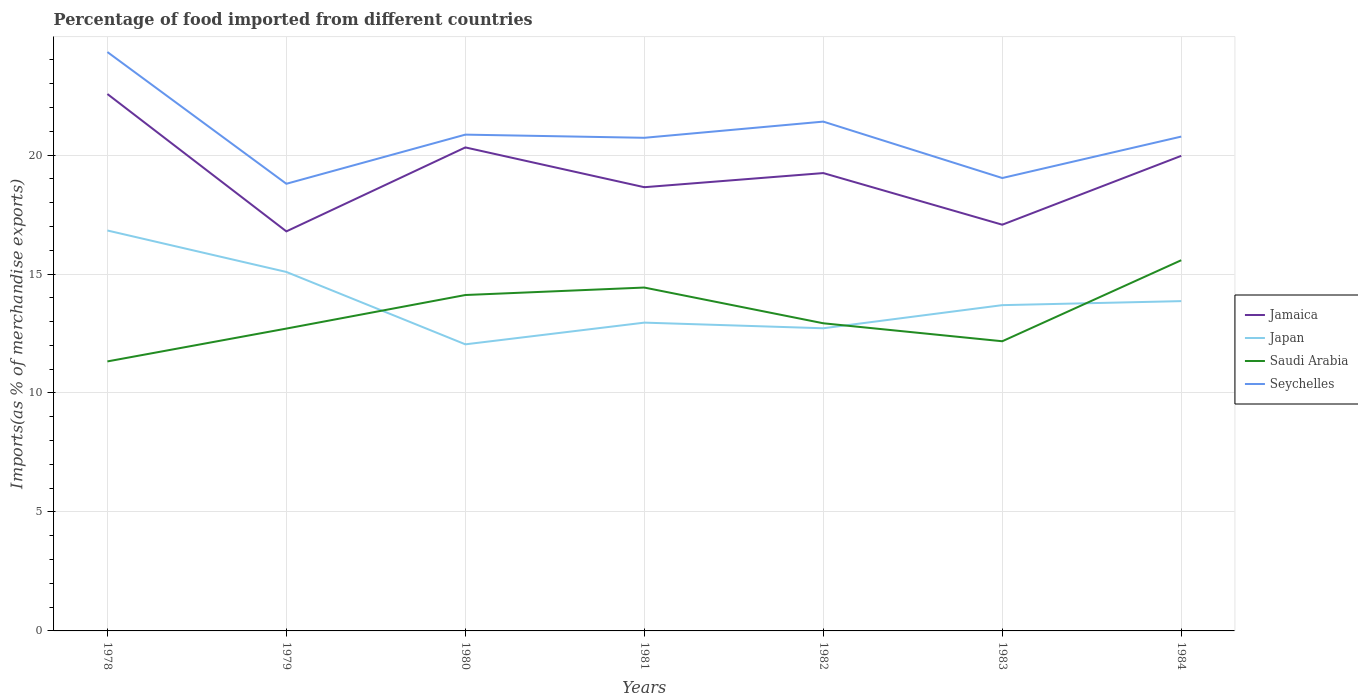Is the number of lines equal to the number of legend labels?
Provide a succinct answer. Yes. Across all years, what is the maximum percentage of imports to different countries in Japan?
Offer a very short reply. 12.04. In which year was the percentage of imports to different countries in Jamaica maximum?
Give a very brief answer. 1979. What is the total percentage of imports to different countries in Saudi Arabia in the graph?
Provide a succinct answer. -0.31. What is the difference between the highest and the second highest percentage of imports to different countries in Saudi Arabia?
Keep it short and to the point. 4.25. What is the difference between the highest and the lowest percentage of imports to different countries in Seychelles?
Provide a succinct answer. 3. How many lines are there?
Give a very brief answer. 4. How many years are there in the graph?
Provide a short and direct response. 7. What is the difference between two consecutive major ticks on the Y-axis?
Your answer should be very brief. 5. Are the values on the major ticks of Y-axis written in scientific E-notation?
Give a very brief answer. No. Does the graph contain any zero values?
Offer a very short reply. No. Does the graph contain grids?
Offer a very short reply. Yes. How are the legend labels stacked?
Offer a terse response. Vertical. What is the title of the graph?
Your answer should be very brief. Percentage of food imported from different countries. What is the label or title of the Y-axis?
Your answer should be compact. Imports(as % of merchandise exports). What is the Imports(as % of merchandise exports) in Jamaica in 1978?
Provide a short and direct response. 22.56. What is the Imports(as % of merchandise exports) in Japan in 1978?
Your answer should be compact. 16.83. What is the Imports(as % of merchandise exports) of Saudi Arabia in 1978?
Your response must be concise. 11.33. What is the Imports(as % of merchandise exports) in Seychelles in 1978?
Ensure brevity in your answer.  24.33. What is the Imports(as % of merchandise exports) in Jamaica in 1979?
Offer a very short reply. 16.79. What is the Imports(as % of merchandise exports) in Japan in 1979?
Offer a terse response. 15.09. What is the Imports(as % of merchandise exports) in Saudi Arabia in 1979?
Provide a short and direct response. 12.71. What is the Imports(as % of merchandise exports) of Seychelles in 1979?
Give a very brief answer. 18.79. What is the Imports(as % of merchandise exports) of Jamaica in 1980?
Offer a very short reply. 20.32. What is the Imports(as % of merchandise exports) in Japan in 1980?
Provide a succinct answer. 12.04. What is the Imports(as % of merchandise exports) of Saudi Arabia in 1980?
Provide a succinct answer. 14.12. What is the Imports(as % of merchandise exports) of Seychelles in 1980?
Offer a terse response. 20.86. What is the Imports(as % of merchandise exports) in Jamaica in 1981?
Provide a short and direct response. 18.65. What is the Imports(as % of merchandise exports) of Japan in 1981?
Your answer should be compact. 12.96. What is the Imports(as % of merchandise exports) in Saudi Arabia in 1981?
Keep it short and to the point. 14.43. What is the Imports(as % of merchandise exports) of Seychelles in 1981?
Make the answer very short. 20.72. What is the Imports(as % of merchandise exports) of Jamaica in 1982?
Your answer should be very brief. 19.24. What is the Imports(as % of merchandise exports) in Japan in 1982?
Provide a short and direct response. 12.72. What is the Imports(as % of merchandise exports) in Saudi Arabia in 1982?
Provide a succinct answer. 12.93. What is the Imports(as % of merchandise exports) in Seychelles in 1982?
Give a very brief answer. 21.4. What is the Imports(as % of merchandise exports) of Jamaica in 1983?
Your answer should be very brief. 17.07. What is the Imports(as % of merchandise exports) of Japan in 1983?
Make the answer very short. 13.69. What is the Imports(as % of merchandise exports) in Saudi Arabia in 1983?
Offer a terse response. 12.17. What is the Imports(as % of merchandise exports) of Seychelles in 1983?
Keep it short and to the point. 19.03. What is the Imports(as % of merchandise exports) of Jamaica in 1984?
Offer a terse response. 19.97. What is the Imports(as % of merchandise exports) in Japan in 1984?
Make the answer very short. 13.86. What is the Imports(as % of merchandise exports) in Saudi Arabia in 1984?
Your answer should be very brief. 15.58. What is the Imports(as % of merchandise exports) of Seychelles in 1984?
Your answer should be very brief. 20.78. Across all years, what is the maximum Imports(as % of merchandise exports) of Jamaica?
Ensure brevity in your answer.  22.56. Across all years, what is the maximum Imports(as % of merchandise exports) of Japan?
Your answer should be compact. 16.83. Across all years, what is the maximum Imports(as % of merchandise exports) of Saudi Arabia?
Provide a succinct answer. 15.58. Across all years, what is the maximum Imports(as % of merchandise exports) in Seychelles?
Ensure brevity in your answer.  24.33. Across all years, what is the minimum Imports(as % of merchandise exports) in Jamaica?
Provide a short and direct response. 16.79. Across all years, what is the minimum Imports(as % of merchandise exports) of Japan?
Provide a succinct answer. 12.04. Across all years, what is the minimum Imports(as % of merchandise exports) of Saudi Arabia?
Your answer should be compact. 11.33. Across all years, what is the minimum Imports(as % of merchandise exports) in Seychelles?
Give a very brief answer. 18.79. What is the total Imports(as % of merchandise exports) of Jamaica in the graph?
Provide a short and direct response. 134.61. What is the total Imports(as % of merchandise exports) of Japan in the graph?
Ensure brevity in your answer.  97.19. What is the total Imports(as % of merchandise exports) of Saudi Arabia in the graph?
Ensure brevity in your answer.  93.26. What is the total Imports(as % of merchandise exports) of Seychelles in the graph?
Provide a short and direct response. 145.92. What is the difference between the Imports(as % of merchandise exports) of Jamaica in 1978 and that in 1979?
Keep it short and to the point. 5.77. What is the difference between the Imports(as % of merchandise exports) of Japan in 1978 and that in 1979?
Your response must be concise. 1.74. What is the difference between the Imports(as % of merchandise exports) of Saudi Arabia in 1978 and that in 1979?
Provide a succinct answer. -1.38. What is the difference between the Imports(as % of merchandise exports) of Seychelles in 1978 and that in 1979?
Your answer should be compact. 5.54. What is the difference between the Imports(as % of merchandise exports) in Jamaica in 1978 and that in 1980?
Offer a very short reply. 2.24. What is the difference between the Imports(as % of merchandise exports) in Japan in 1978 and that in 1980?
Make the answer very short. 4.78. What is the difference between the Imports(as % of merchandise exports) of Saudi Arabia in 1978 and that in 1980?
Make the answer very short. -2.79. What is the difference between the Imports(as % of merchandise exports) in Seychelles in 1978 and that in 1980?
Your answer should be very brief. 3.47. What is the difference between the Imports(as % of merchandise exports) in Jamaica in 1978 and that in 1981?
Make the answer very short. 3.92. What is the difference between the Imports(as % of merchandise exports) in Japan in 1978 and that in 1981?
Offer a terse response. 3.87. What is the difference between the Imports(as % of merchandise exports) of Saudi Arabia in 1978 and that in 1981?
Offer a very short reply. -3.1. What is the difference between the Imports(as % of merchandise exports) in Seychelles in 1978 and that in 1981?
Your answer should be compact. 3.6. What is the difference between the Imports(as % of merchandise exports) in Jamaica in 1978 and that in 1982?
Provide a short and direct response. 3.32. What is the difference between the Imports(as % of merchandise exports) of Japan in 1978 and that in 1982?
Offer a terse response. 4.11. What is the difference between the Imports(as % of merchandise exports) in Saudi Arabia in 1978 and that in 1982?
Provide a short and direct response. -1.6. What is the difference between the Imports(as % of merchandise exports) of Seychelles in 1978 and that in 1982?
Your answer should be very brief. 2.92. What is the difference between the Imports(as % of merchandise exports) in Jamaica in 1978 and that in 1983?
Keep it short and to the point. 5.49. What is the difference between the Imports(as % of merchandise exports) in Japan in 1978 and that in 1983?
Your response must be concise. 3.14. What is the difference between the Imports(as % of merchandise exports) of Saudi Arabia in 1978 and that in 1983?
Provide a short and direct response. -0.85. What is the difference between the Imports(as % of merchandise exports) of Seychelles in 1978 and that in 1983?
Make the answer very short. 5.29. What is the difference between the Imports(as % of merchandise exports) of Jamaica in 1978 and that in 1984?
Offer a very short reply. 2.6. What is the difference between the Imports(as % of merchandise exports) of Japan in 1978 and that in 1984?
Your answer should be very brief. 2.97. What is the difference between the Imports(as % of merchandise exports) of Saudi Arabia in 1978 and that in 1984?
Offer a terse response. -4.25. What is the difference between the Imports(as % of merchandise exports) in Seychelles in 1978 and that in 1984?
Offer a terse response. 3.55. What is the difference between the Imports(as % of merchandise exports) in Jamaica in 1979 and that in 1980?
Your response must be concise. -3.53. What is the difference between the Imports(as % of merchandise exports) in Japan in 1979 and that in 1980?
Offer a very short reply. 3.04. What is the difference between the Imports(as % of merchandise exports) of Saudi Arabia in 1979 and that in 1980?
Provide a succinct answer. -1.41. What is the difference between the Imports(as % of merchandise exports) of Seychelles in 1979 and that in 1980?
Your response must be concise. -2.07. What is the difference between the Imports(as % of merchandise exports) in Jamaica in 1979 and that in 1981?
Give a very brief answer. -1.86. What is the difference between the Imports(as % of merchandise exports) in Japan in 1979 and that in 1981?
Your answer should be very brief. 2.13. What is the difference between the Imports(as % of merchandise exports) of Saudi Arabia in 1979 and that in 1981?
Offer a terse response. -1.72. What is the difference between the Imports(as % of merchandise exports) of Seychelles in 1979 and that in 1981?
Offer a terse response. -1.93. What is the difference between the Imports(as % of merchandise exports) in Jamaica in 1979 and that in 1982?
Your response must be concise. -2.45. What is the difference between the Imports(as % of merchandise exports) in Japan in 1979 and that in 1982?
Ensure brevity in your answer.  2.37. What is the difference between the Imports(as % of merchandise exports) in Saudi Arabia in 1979 and that in 1982?
Provide a succinct answer. -0.22. What is the difference between the Imports(as % of merchandise exports) of Seychelles in 1979 and that in 1982?
Provide a short and direct response. -2.61. What is the difference between the Imports(as % of merchandise exports) in Jamaica in 1979 and that in 1983?
Your response must be concise. -0.28. What is the difference between the Imports(as % of merchandise exports) in Japan in 1979 and that in 1983?
Offer a very short reply. 1.39. What is the difference between the Imports(as % of merchandise exports) of Saudi Arabia in 1979 and that in 1983?
Give a very brief answer. 0.53. What is the difference between the Imports(as % of merchandise exports) of Seychelles in 1979 and that in 1983?
Your answer should be compact. -0.24. What is the difference between the Imports(as % of merchandise exports) of Jamaica in 1979 and that in 1984?
Offer a terse response. -3.17. What is the difference between the Imports(as % of merchandise exports) of Japan in 1979 and that in 1984?
Give a very brief answer. 1.23. What is the difference between the Imports(as % of merchandise exports) of Saudi Arabia in 1979 and that in 1984?
Provide a succinct answer. -2.87. What is the difference between the Imports(as % of merchandise exports) of Seychelles in 1979 and that in 1984?
Your response must be concise. -1.98. What is the difference between the Imports(as % of merchandise exports) in Jamaica in 1980 and that in 1981?
Give a very brief answer. 1.67. What is the difference between the Imports(as % of merchandise exports) in Japan in 1980 and that in 1981?
Your answer should be compact. -0.91. What is the difference between the Imports(as % of merchandise exports) of Saudi Arabia in 1980 and that in 1981?
Provide a succinct answer. -0.31. What is the difference between the Imports(as % of merchandise exports) in Seychelles in 1980 and that in 1981?
Your answer should be very brief. 0.13. What is the difference between the Imports(as % of merchandise exports) of Jamaica in 1980 and that in 1982?
Provide a succinct answer. 1.08. What is the difference between the Imports(as % of merchandise exports) in Japan in 1980 and that in 1982?
Provide a succinct answer. -0.68. What is the difference between the Imports(as % of merchandise exports) of Saudi Arabia in 1980 and that in 1982?
Your response must be concise. 1.19. What is the difference between the Imports(as % of merchandise exports) in Seychelles in 1980 and that in 1982?
Offer a very short reply. -0.55. What is the difference between the Imports(as % of merchandise exports) in Jamaica in 1980 and that in 1983?
Offer a very short reply. 3.25. What is the difference between the Imports(as % of merchandise exports) in Japan in 1980 and that in 1983?
Keep it short and to the point. -1.65. What is the difference between the Imports(as % of merchandise exports) of Saudi Arabia in 1980 and that in 1983?
Your answer should be very brief. 1.94. What is the difference between the Imports(as % of merchandise exports) of Seychelles in 1980 and that in 1983?
Your answer should be compact. 1.82. What is the difference between the Imports(as % of merchandise exports) in Jamaica in 1980 and that in 1984?
Your answer should be very brief. 0.35. What is the difference between the Imports(as % of merchandise exports) in Japan in 1980 and that in 1984?
Provide a short and direct response. -1.82. What is the difference between the Imports(as % of merchandise exports) in Saudi Arabia in 1980 and that in 1984?
Offer a terse response. -1.46. What is the difference between the Imports(as % of merchandise exports) of Seychelles in 1980 and that in 1984?
Provide a short and direct response. 0.08. What is the difference between the Imports(as % of merchandise exports) of Jamaica in 1981 and that in 1982?
Your response must be concise. -0.59. What is the difference between the Imports(as % of merchandise exports) of Japan in 1981 and that in 1982?
Provide a short and direct response. 0.24. What is the difference between the Imports(as % of merchandise exports) in Saudi Arabia in 1981 and that in 1982?
Make the answer very short. 1.5. What is the difference between the Imports(as % of merchandise exports) of Seychelles in 1981 and that in 1982?
Offer a terse response. -0.68. What is the difference between the Imports(as % of merchandise exports) in Jamaica in 1981 and that in 1983?
Make the answer very short. 1.58. What is the difference between the Imports(as % of merchandise exports) in Japan in 1981 and that in 1983?
Offer a very short reply. -0.73. What is the difference between the Imports(as % of merchandise exports) of Saudi Arabia in 1981 and that in 1983?
Make the answer very short. 2.26. What is the difference between the Imports(as % of merchandise exports) in Seychelles in 1981 and that in 1983?
Your response must be concise. 1.69. What is the difference between the Imports(as % of merchandise exports) in Jamaica in 1981 and that in 1984?
Make the answer very short. -1.32. What is the difference between the Imports(as % of merchandise exports) of Japan in 1981 and that in 1984?
Give a very brief answer. -0.9. What is the difference between the Imports(as % of merchandise exports) in Saudi Arabia in 1981 and that in 1984?
Keep it short and to the point. -1.15. What is the difference between the Imports(as % of merchandise exports) in Seychelles in 1981 and that in 1984?
Offer a terse response. -0.05. What is the difference between the Imports(as % of merchandise exports) of Jamaica in 1982 and that in 1983?
Make the answer very short. 2.17. What is the difference between the Imports(as % of merchandise exports) of Japan in 1982 and that in 1983?
Make the answer very short. -0.97. What is the difference between the Imports(as % of merchandise exports) in Saudi Arabia in 1982 and that in 1983?
Provide a succinct answer. 0.76. What is the difference between the Imports(as % of merchandise exports) of Seychelles in 1982 and that in 1983?
Your answer should be compact. 2.37. What is the difference between the Imports(as % of merchandise exports) in Jamaica in 1982 and that in 1984?
Ensure brevity in your answer.  -0.72. What is the difference between the Imports(as % of merchandise exports) in Japan in 1982 and that in 1984?
Provide a short and direct response. -1.14. What is the difference between the Imports(as % of merchandise exports) of Saudi Arabia in 1982 and that in 1984?
Offer a very short reply. -2.65. What is the difference between the Imports(as % of merchandise exports) of Seychelles in 1982 and that in 1984?
Your response must be concise. 0.63. What is the difference between the Imports(as % of merchandise exports) in Jamaica in 1983 and that in 1984?
Offer a terse response. -2.89. What is the difference between the Imports(as % of merchandise exports) in Japan in 1983 and that in 1984?
Your response must be concise. -0.17. What is the difference between the Imports(as % of merchandise exports) in Saudi Arabia in 1983 and that in 1984?
Offer a very short reply. -3.41. What is the difference between the Imports(as % of merchandise exports) in Seychelles in 1983 and that in 1984?
Keep it short and to the point. -1.74. What is the difference between the Imports(as % of merchandise exports) in Jamaica in 1978 and the Imports(as % of merchandise exports) in Japan in 1979?
Offer a very short reply. 7.48. What is the difference between the Imports(as % of merchandise exports) of Jamaica in 1978 and the Imports(as % of merchandise exports) of Saudi Arabia in 1979?
Ensure brevity in your answer.  9.86. What is the difference between the Imports(as % of merchandise exports) of Jamaica in 1978 and the Imports(as % of merchandise exports) of Seychelles in 1979?
Your answer should be compact. 3.77. What is the difference between the Imports(as % of merchandise exports) of Japan in 1978 and the Imports(as % of merchandise exports) of Saudi Arabia in 1979?
Make the answer very short. 4.12. What is the difference between the Imports(as % of merchandise exports) of Japan in 1978 and the Imports(as % of merchandise exports) of Seychelles in 1979?
Provide a short and direct response. -1.96. What is the difference between the Imports(as % of merchandise exports) in Saudi Arabia in 1978 and the Imports(as % of merchandise exports) in Seychelles in 1979?
Offer a very short reply. -7.47. What is the difference between the Imports(as % of merchandise exports) of Jamaica in 1978 and the Imports(as % of merchandise exports) of Japan in 1980?
Make the answer very short. 10.52. What is the difference between the Imports(as % of merchandise exports) of Jamaica in 1978 and the Imports(as % of merchandise exports) of Saudi Arabia in 1980?
Give a very brief answer. 8.45. What is the difference between the Imports(as % of merchandise exports) in Jamaica in 1978 and the Imports(as % of merchandise exports) in Seychelles in 1980?
Your answer should be compact. 1.71. What is the difference between the Imports(as % of merchandise exports) in Japan in 1978 and the Imports(as % of merchandise exports) in Saudi Arabia in 1980?
Give a very brief answer. 2.71. What is the difference between the Imports(as % of merchandise exports) of Japan in 1978 and the Imports(as % of merchandise exports) of Seychelles in 1980?
Offer a very short reply. -4.03. What is the difference between the Imports(as % of merchandise exports) in Saudi Arabia in 1978 and the Imports(as % of merchandise exports) in Seychelles in 1980?
Offer a terse response. -9.53. What is the difference between the Imports(as % of merchandise exports) of Jamaica in 1978 and the Imports(as % of merchandise exports) of Japan in 1981?
Provide a succinct answer. 9.61. What is the difference between the Imports(as % of merchandise exports) in Jamaica in 1978 and the Imports(as % of merchandise exports) in Saudi Arabia in 1981?
Give a very brief answer. 8.13. What is the difference between the Imports(as % of merchandise exports) of Jamaica in 1978 and the Imports(as % of merchandise exports) of Seychelles in 1981?
Make the answer very short. 1.84. What is the difference between the Imports(as % of merchandise exports) in Japan in 1978 and the Imports(as % of merchandise exports) in Saudi Arabia in 1981?
Ensure brevity in your answer.  2.4. What is the difference between the Imports(as % of merchandise exports) in Japan in 1978 and the Imports(as % of merchandise exports) in Seychelles in 1981?
Your response must be concise. -3.9. What is the difference between the Imports(as % of merchandise exports) of Saudi Arabia in 1978 and the Imports(as % of merchandise exports) of Seychelles in 1981?
Your answer should be compact. -9.4. What is the difference between the Imports(as % of merchandise exports) of Jamaica in 1978 and the Imports(as % of merchandise exports) of Japan in 1982?
Make the answer very short. 9.85. What is the difference between the Imports(as % of merchandise exports) of Jamaica in 1978 and the Imports(as % of merchandise exports) of Saudi Arabia in 1982?
Keep it short and to the point. 9.64. What is the difference between the Imports(as % of merchandise exports) of Jamaica in 1978 and the Imports(as % of merchandise exports) of Seychelles in 1982?
Your answer should be compact. 1.16. What is the difference between the Imports(as % of merchandise exports) of Japan in 1978 and the Imports(as % of merchandise exports) of Saudi Arabia in 1982?
Offer a terse response. 3.9. What is the difference between the Imports(as % of merchandise exports) in Japan in 1978 and the Imports(as % of merchandise exports) in Seychelles in 1982?
Your answer should be very brief. -4.58. What is the difference between the Imports(as % of merchandise exports) of Saudi Arabia in 1978 and the Imports(as % of merchandise exports) of Seychelles in 1982?
Ensure brevity in your answer.  -10.08. What is the difference between the Imports(as % of merchandise exports) in Jamaica in 1978 and the Imports(as % of merchandise exports) in Japan in 1983?
Provide a short and direct response. 8.87. What is the difference between the Imports(as % of merchandise exports) in Jamaica in 1978 and the Imports(as % of merchandise exports) in Saudi Arabia in 1983?
Your response must be concise. 10.39. What is the difference between the Imports(as % of merchandise exports) of Jamaica in 1978 and the Imports(as % of merchandise exports) of Seychelles in 1983?
Your answer should be very brief. 3.53. What is the difference between the Imports(as % of merchandise exports) of Japan in 1978 and the Imports(as % of merchandise exports) of Saudi Arabia in 1983?
Give a very brief answer. 4.65. What is the difference between the Imports(as % of merchandise exports) of Japan in 1978 and the Imports(as % of merchandise exports) of Seychelles in 1983?
Offer a very short reply. -2.21. What is the difference between the Imports(as % of merchandise exports) of Saudi Arabia in 1978 and the Imports(as % of merchandise exports) of Seychelles in 1983?
Your response must be concise. -7.71. What is the difference between the Imports(as % of merchandise exports) of Jamaica in 1978 and the Imports(as % of merchandise exports) of Japan in 1984?
Give a very brief answer. 8.7. What is the difference between the Imports(as % of merchandise exports) of Jamaica in 1978 and the Imports(as % of merchandise exports) of Saudi Arabia in 1984?
Your answer should be very brief. 6.99. What is the difference between the Imports(as % of merchandise exports) of Jamaica in 1978 and the Imports(as % of merchandise exports) of Seychelles in 1984?
Offer a very short reply. 1.79. What is the difference between the Imports(as % of merchandise exports) in Japan in 1978 and the Imports(as % of merchandise exports) in Saudi Arabia in 1984?
Make the answer very short. 1.25. What is the difference between the Imports(as % of merchandise exports) in Japan in 1978 and the Imports(as % of merchandise exports) in Seychelles in 1984?
Provide a short and direct response. -3.95. What is the difference between the Imports(as % of merchandise exports) in Saudi Arabia in 1978 and the Imports(as % of merchandise exports) in Seychelles in 1984?
Your answer should be compact. -9.45. What is the difference between the Imports(as % of merchandise exports) in Jamaica in 1979 and the Imports(as % of merchandise exports) in Japan in 1980?
Offer a terse response. 4.75. What is the difference between the Imports(as % of merchandise exports) of Jamaica in 1979 and the Imports(as % of merchandise exports) of Saudi Arabia in 1980?
Give a very brief answer. 2.67. What is the difference between the Imports(as % of merchandise exports) in Jamaica in 1979 and the Imports(as % of merchandise exports) in Seychelles in 1980?
Give a very brief answer. -4.07. What is the difference between the Imports(as % of merchandise exports) in Japan in 1979 and the Imports(as % of merchandise exports) in Saudi Arabia in 1980?
Make the answer very short. 0.97. What is the difference between the Imports(as % of merchandise exports) in Japan in 1979 and the Imports(as % of merchandise exports) in Seychelles in 1980?
Your answer should be very brief. -5.77. What is the difference between the Imports(as % of merchandise exports) of Saudi Arabia in 1979 and the Imports(as % of merchandise exports) of Seychelles in 1980?
Provide a succinct answer. -8.15. What is the difference between the Imports(as % of merchandise exports) in Jamaica in 1979 and the Imports(as % of merchandise exports) in Japan in 1981?
Your answer should be very brief. 3.84. What is the difference between the Imports(as % of merchandise exports) of Jamaica in 1979 and the Imports(as % of merchandise exports) of Saudi Arabia in 1981?
Your answer should be very brief. 2.36. What is the difference between the Imports(as % of merchandise exports) in Jamaica in 1979 and the Imports(as % of merchandise exports) in Seychelles in 1981?
Give a very brief answer. -3.93. What is the difference between the Imports(as % of merchandise exports) in Japan in 1979 and the Imports(as % of merchandise exports) in Saudi Arabia in 1981?
Ensure brevity in your answer.  0.66. What is the difference between the Imports(as % of merchandise exports) in Japan in 1979 and the Imports(as % of merchandise exports) in Seychelles in 1981?
Give a very brief answer. -5.64. What is the difference between the Imports(as % of merchandise exports) of Saudi Arabia in 1979 and the Imports(as % of merchandise exports) of Seychelles in 1981?
Your answer should be compact. -8.02. What is the difference between the Imports(as % of merchandise exports) in Jamaica in 1979 and the Imports(as % of merchandise exports) in Japan in 1982?
Ensure brevity in your answer.  4.07. What is the difference between the Imports(as % of merchandise exports) of Jamaica in 1979 and the Imports(as % of merchandise exports) of Saudi Arabia in 1982?
Keep it short and to the point. 3.86. What is the difference between the Imports(as % of merchandise exports) in Jamaica in 1979 and the Imports(as % of merchandise exports) in Seychelles in 1982?
Your response must be concise. -4.61. What is the difference between the Imports(as % of merchandise exports) of Japan in 1979 and the Imports(as % of merchandise exports) of Saudi Arabia in 1982?
Your answer should be very brief. 2.16. What is the difference between the Imports(as % of merchandise exports) of Japan in 1979 and the Imports(as % of merchandise exports) of Seychelles in 1982?
Offer a very short reply. -6.32. What is the difference between the Imports(as % of merchandise exports) of Saudi Arabia in 1979 and the Imports(as % of merchandise exports) of Seychelles in 1982?
Offer a very short reply. -8.7. What is the difference between the Imports(as % of merchandise exports) in Jamaica in 1979 and the Imports(as % of merchandise exports) in Japan in 1983?
Provide a succinct answer. 3.1. What is the difference between the Imports(as % of merchandise exports) in Jamaica in 1979 and the Imports(as % of merchandise exports) in Saudi Arabia in 1983?
Give a very brief answer. 4.62. What is the difference between the Imports(as % of merchandise exports) of Jamaica in 1979 and the Imports(as % of merchandise exports) of Seychelles in 1983?
Your answer should be compact. -2.24. What is the difference between the Imports(as % of merchandise exports) in Japan in 1979 and the Imports(as % of merchandise exports) in Saudi Arabia in 1983?
Offer a very short reply. 2.91. What is the difference between the Imports(as % of merchandise exports) in Japan in 1979 and the Imports(as % of merchandise exports) in Seychelles in 1983?
Provide a short and direct response. -3.95. What is the difference between the Imports(as % of merchandise exports) of Saudi Arabia in 1979 and the Imports(as % of merchandise exports) of Seychelles in 1983?
Your answer should be compact. -6.33. What is the difference between the Imports(as % of merchandise exports) in Jamaica in 1979 and the Imports(as % of merchandise exports) in Japan in 1984?
Your answer should be very brief. 2.93. What is the difference between the Imports(as % of merchandise exports) in Jamaica in 1979 and the Imports(as % of merchandise exports) in Saudi Arabia in 1984?
Offer a very short reply. 1.21. What is the difference between the Imports(as % of merchandise exports) in Jamaica in 1979 and the Imports(as % of merchandise exports) in Seychelles in 1984?
Provide a succinct answer. -3.98. What is the difference between the Imports(as % of merchandise exports) in Japan in 1979 and the Imports(as % of merchandise exports) in Saudi Arabia in 1984?
Ensure brevity in your answer.  -0.49. What is the difference between the Imports(as % of merchandise exports) in Japan in 1979 and the Imports(as % of merchandise exports) in Seychelles in 1984?
Make the answer very short. -5.69. What is the difference between the Imports(as % of merchandise exports) of Saudi Arabia in 1979 and the Imports(as % of merchandise exports) of Seychelles in 1984?
Make the answer very short. -8.07. What is the difference between the Imports(as % of merchandise exports) in Jamaica in 1980 and the Imports(as % of merchandise exports) in Japan in 1981?
Ensure brevity in your answer.  7.36. What is the difference between the Imports(as % of merchandise exports) in Jamaica in 1980 and the Imports(as % of merchandise exports) in Saudi Arabia in 1981?
Provide a short and direct response. 5.89. What is the difference between the Imports(as % of merchandise exports) in Jamaica in 1980 and the Imports(as % of merchandise exports) in Seychelles in 1981?
Ensure brevity in your answer.  -0.4. What is the difference between the Imports(as % of merchandise exports) of Japan in 1980 and the Imports(as % of merchandise exports) of Saudi Arabia in 1981?
Give a very brief answer. -2.39. What is the difference between the Imports(as % of merchandise exports) in Japan in 1980 and the Imports(as % of merchandise exports) in Seychelles in 1981?
Keep it short and to the point. -8.68. What is the difference between the Imports(as % of merchandise exports) of Saudi Arabia in 1980 and the Imports(as % of merchandise exports) of Seychelles in 1981?
Offer a terse response. -6.61. What is the difference between the Imports(as % of merchandise exports) of Jamaica in 1980 and the Imports(as % of merchandise exports) of Japan in 1982?
Provide a succinct answer. 7.6. What is the difference between the Imports(as % of merchandise exports) of Jamaica in 1980 and the Imports(as % of merchandise exports) of Saudi Arabia in 1982?
Your answer should be very brief. 7.39. What is the difference between the Imports(as % of merchandise exports) of Jamaica in 1980 and the Imports(as % of merchandise exports) of Seychelles in 1982?
Provide a short and direct response. -1.08. What is the difference between the Imports(as % of merchandise exports) in Japan in 1980 and the Imports(as % of merchandise exports) in Saudi Arabia in 1982?
Offer a terse response. -0.88. What is the difference between the Imports(as % of merchandise exports) in Japan in 1980 and the Imports(as % of merchandise exports) in Seychelles in 1982?
Provide a succinct answer. -9.36. What is the difference between the Imports(as % of merchandise exports) in Saudi Arabia in 1980 and the Imports(as % of merchandise exports) in Seychelles in 1982?
Give a very brief answer. -7.29. What is the difference between the Imports(as % of merchandise exports) in Jamaica in 1980 and the Imports(as % of merchandise exports) in Japan in 1983?
Provide a short and direct response. 6.63. What is the difference between the Imports(as % of merchandise exports) in Jamaica in 1980 and the Imports(as % of merchandise exports) in Saudi Arabia in 1983?
Provide a short and direct response. 8.15. What is the difference between the Imports(as % of merchandise exports) of Jamaica in 1980 and the Imports(as % of merchandise exports) of Seychelles in 1983?
Keep it short and to the point. 1.29. What is the difference between the Imports(as % of merchandise exports) of Japan in 1980 and the Imports(as % of merchandise exports) of Saudi Arabia in 1983?
Your response must be concise. -0.13. What is the difference between the Imports(as % of merchandise exports) of Japan in 1980 and the Imports(as % of merchandise exports) of Seychelles in 1983?
Offer a terse response. -6.99. What is the difference between the Imports(as % of merchandise exports) in Saudi Arabia in 1980 and the Imports(as % of merchandise exports) in Seychelles in 1983?
Provide a short and direct response. -4.92. What is the difference between the Imports(as % of merchandise exports) in Jamaica in 1980 and the Imports(as % of merchandise exports) in Japan in 1984?
Make the answer very short. 6.46. What is the difference between the Imports(as % of merchandise exports) of Jamaica in 1980 and the Imports(as % of merchandise exports) of Saudi Arabia in 1984?
Your response must be concise. 4.74. What is the difference between the Imports(as % of merchandise exports) of Jamaica in 1980 and the Imports(as % of merchandise exports) of Seychelles in 1984?
Keep it short and to the point. -0.46. What is the difference between the Imports(as % of merchandise exports) of Japan in 1980 and the Imports(as % of merchandise exports) of Saudi Arabia in 1984?
Give a very brief answer. -3.53. What is the difference between the Imports(as % of merchandise exports) in Japan in 1980 and the Imports(as % of merchandise exports) in Seychelles in 1984?
Provide a succinct answer. -8.73. What is the difference between the Imports(as % of merchandise exports) in Saudi Arabia in 1980 and the Imports(as % of merchandise exports) in Seychelles in 1984?
Keep it short and to the point. -6.66. What is the difference between the Imports(as % of merchandise exports) in Jamaica in 1981 and the Imports(as % of merchandise exports) in Japan in 1982?
Your answer should be very brief. 5.93. What is the difference between the Imports(as % of merchandise exports) in Jamaica in 1981 and the Imports(as % of merchandise exports) in Saudi Arabia in 1982?
Your response must be concise. 5.72. What is the difference between the Imports(as % of merchandise exports) of Jamaica in 1981 and the Imports(as % of merchandise exports) of Seychelles in 1982?
Provide a succinct answer. -2.76. What is the difference between the Imports(as % of merchandise exports) in Japan in 1981 and the Imports(as % of merchandise exports) in Saudi Arabia in 1982?
Ensure brevity in your answer.  0.03. What is the difference between the Imports(as % of merchandise exports) in Japan in 1981 and the Imports(as % of merchandise exports) in Seychelles in 1982?
Provide a succinct answer. -8.45. What is the difference between the Imports(as % of merchandise exports) of Saudi Arabia in 1981 and the Imports(as % of merchandise exports) of Seychelles in 1982?
Ensure brevity in your answer.  -6.97. What is the difference between the Imports(as % of merchandise exports) in Jamaica in 1981 and the Imports(as % of merchandise exports) in Japan in 1983?
Ensure brevity in your answer.  4.96. What is the difference between the Imports(as % of merchandise exports) of Jamaica in 1981 and the Imports(as % of merchandise exports) of Saudi Arabia in 1983?
Your answer should be compact. 6.47. What is the difference between the Imports(as % of merchandise exports) of Jamaica in 1981 and the Imports(as % of merchandise exports) of Seychelles in 1983?
Your response must be concise. -0.39. What is the difference between the Imports(as % of merchandise exports) in Japan in 1981 and the Imports(as % of merchandise exports) in Saudi Arabia in 1983?
Make the answer very short. 0.78. What is the difference between the Imports(as % of merchandise exports) of Japan in 1981 and the Imports(as % of merchandise exports) of Seychelles in 1983?
Keep it short and to the point. -6.08. What is the difference between the Imports(as % of merchandise exports) in Saudi Arabia in 1981 and the Imports(as % of merchandise exports) in Seychelles in 1983?
Your answer should be very brief. -4.6. What is the difference between the Imports(as % of merchandise exports) of Jamaica in 1981 and the Imports(as % of merchandise exports) of Japan in 1984?
Ensure brevity in your answer.  4.79. What is the difference between the Imports(as % of merchandise exports) in Jamaica in 1981 and the Imports(as % of merchandise exports) in Saudi Arabia in 1984?
Your response must be concise. 3.07. What is the difference between the Imports(as % of merchandise exports) in Jamaica in 1981 and the Imports(as % of merchandise exports) in Seychelles in 1984?
Offer a terse response. -2.13. What is the difference between the Imports(as % of merchandise exports) in Japan in 1981 and the Imports(as % of merchandise exports) in Saudi Arabia in 1984?
Offer a terse response. -2.62. What is the difference between the Imports(as % of merchandise exports) of Japan in 1981 and the Imports(as % of merchandise exports) of Seychelles in 1984?
Provide a succinct answer. -7.82. What is the difference between the Imports(as % of merchandise exports) in Saudi Arabia in 1981 and the Imports(as % of merchandise exports) in Seychelles in 1984?
Your response must be concise. -6.34. What is the difference between the Imports(as % of merchandise exports) of Jamaica in 1982 and the Imports(as % of merchandise exports) of Japan in 1983?
Keep it short and to the point. 5.55. What is the difference between the Imports(as % of merchandise exports) in Jamaica in 1982 and the Imports(as % of merchandise exports) in Saudi Arabia in 1983?
Offer a very short reply. 7.07. What is the difference between the Imports(as % of merchandise exports) of Jamaica in 1982 and the Imports(as % of merchandise exports) of Seychelles in 1983?
Give a very brief answer. 0.21. What is the difference between the Imports(as % of merchandise exports) in Japan in 1982 and the Imports(as % of merchandise exports) in Saudi Arabia in 1983?
Your answer should be very brief. 0.55. What is the difference between the Imports(as % of merchandise exports) in Japan in 1982 and the Imports(as % of merchandise exports) in Seychelles in 1983?
Keep it short and to the point. -6.31. What is the difference between the Imports(as % of merchandise exports) in Saudi Arabia in 1982 and the Imports(as % of merchandise exports) in Seychelles in 1983?
Offer a very short reply. -6.1. What is the difference between the Imports(as % of merchandise exports) of Jamaica in 1982 and the Imports(as % of merchandise exports) of Japan in 1984?
Your response must be concise. 5.38. What is the difference between the Imports(as % of merchandise exports) in Jamaica in 1982 and the Imports(as % of merchandise exports) in Saudi Arabia in 1984?
Make the answer very short. 3.66. What is the difference between the Imports(as % of merchandise exports) in Jamaica in 1982 and the Imports(as % of merchandise exports) in Seychelles in 1984?
Offer a very short reply. -1.53. What is the difference between the Imports(as % of merchandise exports) of Japan in 1982 and the Imports(as % of merchandise exports) of Saudi Arabia in 1984?
Offer a terse response. -2.86. What is the difference between the Imports(as % of merchandise exports) in Japan in 1982 and the Imports(as % of merchandise exports) in Seychelles in 1984?
Your answer should be very brief. -8.06. What is the difference between the Imports(as % of merchandise exports) in Saudi Arabia in 1982 and the Imports(as % of merchandise exports) in Seychelles in 1984?
Your answer should be very brief. -7.85. What is the difference between the Imports(as % of merchandise exports) in Jamaica in 1983 and the Imports(as % of merchandise exports) in Japan in 1984?
Provide a short and direct response. 3.21. What is the difference between the Imports(as % of merchandise exports) of Jamaica in 1983 and the Imports(as % of merchandise exports) of Saudi Arabia in 1984?
Provide a succinct answer. 1.49. What is the difference between the Imports(as % of merchandise exports) of Jamaica in 1983 and the Imports(as % of merchandise exports) of Seychelles in 1984?
Ensure brevity in your answer.  -3.7. What is the difference between the Imports(as % of merchandise exports) of Japan in 1983 and the Imports(as % of merchandise exports) of Saudi Arabia in 1984?
Your response must be concise. -1.89. What is the difference between the Imports(as % of merchandise exports) in Japan in 1983 and the Imports(as % of merchandise exports) in Seychelles in 1984?
Make the answer very short. -7.08. What is the difference between the Imports(as % of merchandise exports) in Saudi Arabia in 1983 and the Imports(as % of merchandise exports) in Seychelles in 1984?
Ensure brevity in your answer.  -8.6. What is the average Imports(as % of merchandise exports) in Jamaica per year?
Make the answer very short. 19.23. What is the average Imports(as % of merchandise exports) in Japan per year?
Provide a short and direct response. 13.88. What is the average Imports(as % of merchandise exports) of Saudi Arabia per year?
Offer a terse response. 13.32. What is the average Imports(as % of merchandise exports) in Seychelles per year?
Keep it short and to the point. 20.85. In the year 1978, what is the difference between the Imports(as % of merchandise exports) in Jamaica and Imports(as % of merchandise exports) in Japan?
Provide a succinct answer. 5.74. In the year 1978, what is the difference between the Imports(as % of merchandise exports) in Jamaica and Imports(as % of merchandise exports) in Saudi Arabia?
Offer a terse response. 11.24. In the year 1978, what is the difference between the Imports(as % of merchandise exports) in Jamaica and Imports(as % of merchandise exports) in Seychelles?
Give a very brief answer. -1.76. In the year 1978, what is the difference between the Imports(as % of merchandise exports) of Japan and Imports(as % of merchandise exports) of Saudi Arabia?
Give a very brief answer. 5.5. In the year 1978, what is the difference between the Imports(as % of merchandise exports) in Japan and Imports(as % of merchandise exports) in Seychelles?
Ensure brevity in your answer.  -7.5. In the year 1978, what is the difference between the Imports(as % of merchandise exports) in Saudi Arabia and Imports(as % of merchandise exports) in Seychelles?
Give a very brief answer. -13. In the year 1979, what is the difference between the Imports(as % of merchandise exports) in Jamaica and Imports(as % of merchandise exports) in Japan?
Offer a very short reply. 1.71. In the year 1979, what is the difference between the Imports(as % of merchandise exports) in Jamaica and Imports(as % of merchandise exports) in Saudi Arabia?
Make the answer very short. 4.09. In the year 1979, what is the difference between the Imports(as % of merchandise exports) in Jamaica and Imports(as % of merchandise exports) in Seychelles?
Give a very brief answer. -2. In the year 1979, what is the difference between the Imports(as % of merchandise exports) of Japan and Imports(as % of merchandise exports) of Saudi Arabia?
Provide a short and direct response. 2.38. In the year 1979, what is the difference between the Imports(as % of merchandise exports) of Japan and Imports(as % of merchandise exports) of Seychelles?
Offer a terse response. -3.71. In the year 1979, what is the difference between the Imports(as % of merchandise exports) in Saudi Arabia and Imports(as % of merchandise exports) in Seychelles?
Ensure brevity in your answer.  -6.09. In the year 1980, what is the difference between the Imports(as % of merchandise exports) in Jamaica and Imports(as % of merchandise exports) in Japan?
Make the answer very short. 8.28. In the year 1980, what is the difference between the Imports(as % of merchandise exports) of Jamaica and Imports(as % of merchandise exports) of Saudi Arabia?
Your answer should be very brief. 6.2. In the year 1980, what is the difference between the Imports(as % of merchandise exports) in Jamaica and Imports(as % of merchandise exports) in Seychelles?
Provide a succinct answer. -0.54. In the year 1980, what is the difference between the Imports(as % of merchandise exports) of Japan and Imports(as % of merchandise exports) of Saudi Arabia?
Offer a terse response. -2.07. In the year 1980, what is the difference between the Imports(as % of merchandise exports) in Japan and Imports(as % of merchandise exports) in Seychelles?
Provide a short and direct response. -8.81. In the year 1980, what is the difference between the Imports(as % of merchandise exports) in Saudi Arabia and Imports(as % of merchandise exports) in Seychelles?
Your answer should be very brief. -6.74. In the year 1981, what is the difference between the Imports(as % of merchandise exports) of Jamaica and Imports(as % of merchandise exports) of Japan?
Ensure brevity in your answer.  5.69. In the year 1981, what is the difference between the Imports(as % of merchandise exports) in Jamaica and Imports(as % of merchandise exports) in Saudi Arabia?
Your answer should be very brief. 4.22. In the year 1981, what is the difference between the Imports(as % of merchandise exports) of Jamaica and Imports(as % of merchandise exports) of Seychelles?
Keep it short and to the point. -2.08. In the year 1981, what is the difference between the Imports(as % of merchandise exports) of Japan and Imports(as % of merchandise exports) of Saudi Arabia?
Provide a succinct answer. -1.47. In the year 1981, what is the difference between the Imports(as % of merchandise exports) of Japan and Imports(as % of merchandise exports) of Seychelles?
Your answer should be compact. -7.77. In the year 1981, what is the difference between the Imports(as % of merchandise exports) in Saudi Arabia and Imports(as % of merchandise exports) in Seychelles?
Your answer should be very brief. -6.29. In the year 1982, what is the difference between the Imports(as % of merchandise exports) of Jamaica and Imports(as % of merchandise exports) of Japan?
Offer a very short reply. 6.52. In the year 1982, what is the difference between the Imports(as % of merchandise exports) in Jamaica and Imports(as % of merchandise exports) in Saudi Arabia?
Your answer should be very brief. 6.31. In the year 1982, what is the difference between the Imports(as % of merchandise exports) of Jamaica and Imports(as % of merchandise exports) of Seychelles?
Your answer should be very brief. -2.16. In the year 1982, what is the difference between the Imports(as % of merchandise exports) in Japan and Imports(as % of merchandise exports) in Saudi Arabia?
Offer a terse response. -0.21. In the year 1982, what is the difference between the Imports(as % of merchandise exports) in Japan and Imports(as % of merchandise exports) in Seychelles?
Offer a terse response. -8.69. In the year 1982, what is the difference between the Imports(as % of merchandise exports) in Saudi Arabia and Imports(as % of merchandise exports) in Seychelles?
Keep it short and to the point. -8.48. In the year 1983, what is the difference between the Imports(as % of merchandise exports) in Jamaica and Imports(as % of merchandise exports) in Japan?
Your answer should be compact. 3.38. In the year 1983, what is the difference between the Imports(as % of merchandise exports) of Jamaica and Imports(as % of merchandise exports) of Saudi Arabia?
Keep it short and to the point. 4.9. In the year 1983, what is the difference between the Imports(as % of merchandise exports) in Jamaica and Imports(as % of merchandise exports) in Seychelles?
Offer a very short reply. -1.96. In the year 1983, what is the difference between the Imports(as % of merchandise exports) in Japan and Imports(as % of merchandise exports) in Saudi Arabia?
Provide a short and direct response. 1.52. In the year 1983, what is the difference between the Imports(as % of merchandise exports) of Japan and Imports(as % of merchandise exports) of Seychelles?
Offer a very short reply. -5.34. In the year 1983, what is the difference between the Imports(as % of merchandise exports) in Saudi Arabia and Imports(as % of merchandise exports) in Seychelles?
Provide a succinct answer. -6.86. In the year 1984, what is the difference between the Imports(as % of merchandise exports) of Jamaica and Imports(as % of merchandise exports) of Japan?
Offer a very short reply. 6.11. In the year 1984, what is the difference between the Imports(as % of merchandise exports) of Jamaica and Imports(as % of merchandise exports) of Saudi Arabia?
Provide a succinct answer. 4.39. In the year 1984, what is the difference between the Imports(as % of merchandise exports) in Jamaica and Imports(as % of merchandise exports) in Seychelles?
Your response must be concise. -0.81. In the year 1984, what is the difference between the Imports(as % of merchandise exports) in Japan and Imports(as % of merchandise exports) in Saudi Arabia?
Keep it short and to the point. -1.72. In the year 1984, what is the difference between the Imports(as % of merchandise exports) of Japan and Imports(as % of merchandise exports) of Seychelles?
Your response must be concise. -6.92. In the year 1984, what is the difference between the Imports(as % of merchandise exports) in Saudi Arabia and Imports(as % of merchandise exports) in Seychelles?
Your answer should be very brief. -5.2. What is the ratio of the Imports(as % of merchandise exports) in Jamaica in 1978 to that in 1979?
Offer a very short reply. 1.34. What is the ratio of the Imports(as % of merchandise exports) in Japan in 1978 to that in 1979?
Offer a very short reply. 1.12. What is the ratio of the Imports(as % of merchandise exports) in Saudi Arabia in 1978 to that in 1979?
Ensure brevity in your answer.  0.89. What is the ratio of the Imports(as % of merchandise exports) of Seychelles in 1978 to that in 1979?
Offer a terse response. 1.29. What is the ratio of the Imports(as % of merchandise exports) of Jamaica in 1978 to that in 1980?
Your answer should be very brief. 1.11. What is the ratio of the Imports(as % of merchandise exports) of Japan in 1978 to that in 1980?
Make the answer very short. 1.4. What is the ratio of the Imports(as % of merchandise exports) of Saudi Arabia in 1978 to that in 1980?
Make the answer very short. 0.8. What is the ratio of the Imports(as % of merchandise exports) of Seychelles in 1978 to that in 1980?
Keep it short and to the point. 1.17. What is the ratio of the Imports(as % of merchandise exports) of Jamaica in 1978 to that in 1981?
Give a very brief answer. 1.21. What is the ratio of the Imports(as % of merchandise exports) of Japan in 1978 to that in 1981?
Your answer should be very brief. 1.3. What is the ratio of the Imports(as % of merchandise exports) of Saudi Arabia in 1978 to that in 1981?
Your answer should be compact. 0.78. What is the ratio of the Imports(as % of merchandise exports) in Seychelles in 1978 to that in 1981?
Provide a short and direct response. 1.17. What is the ratio of the Imports(as % of merchandise exports) in Jamaica in 1978 to that in 1982?
Provide a succinct answer. 1.17. What is the ratio of the Imports(as % of merchandise exports) of Japan in 1978 to that in 1982?
Your response must be concise. 1.32. What is the ratio of the Imports(as % of merchandise exports) of Saudi Arabia in 1978 to that in 1982?
Your answer should be very brief. 0.88. What is the ratio of the Imports(as % of merchandise exports) in Seychelles in 1978 to that in 1982?
Your answer should be compact. 1.14. What is the ratio of the Imports(as % of merchandise exports) in Jamaica in 1978 to that in 1983?
Your answer should be compact. 1.32. What is the ratio of the Imports(as % of merchandise exports) of Japan in 1978 to that in 1983?
Provide a succinct answer. 1.23. What is the ratio of the Imports(as % of merchandise exports) in Saudi Arabia in 1978 to that in 1983?
Provide a succinct answer. 0.93. What is the ratio of the Imports(as % of merchandise exports) in Seychelles in 1978 to that in 1983?
Your answer should be compact. 1.28. What is the ratio of the Imports(as % of merchandise exports) of Jamaica in 1978 to that in 1984?
Offer a terse response. 1.13. What is the ratio of the Imports(as % of merchandise exports) in Japan in 1978 to that in 1984?
Your response must be concise. 1.21. What is the ratio of the Imports(as % of merchandise exports) of Saudi Arabia in 1978 to that in 1984?
Make the answer very short. 0.73. What is the ratio of the Imports(as % of merchandise exports) of Seychelles in 1978 to that in 1984?
Make the answer very short. 1.17. What is the ratio of the Imports(as % of merchandise exports) of Jamaica in 1979 to that in 1980?
Your answer should be compact. 0.83. What is the ratio of the Imports(as % of merchandise exports) of Japan in 1979 to that in 1980?
Keep it short and to the point. 1.25. What is the ratio of the Imports(as % of merchandise exports) in Saudi Arabia in 1979 to that in 1980?
Keep it short and to the point. 0.9. What is the ratio of the Imports(as % of merchandise exports) in Seychelles in 1979 to that in 1980?
Your response must be concise. 0.9. What is the ratio of the Imports(as % of merchandise exports) in Jamaica in 1979 to that in 1981?
Offer a terse response. 0.9. What is the ratio of the Imports(as % of merchandise exports) in Japan in 1979 to that in 1981?
Make the answer very short. 1.16. What is the ratio of the Imports(as % of merchandise exports) of Saudi Arabia in 1979 to that in 1981?
Keep it short and to the point. 0.88. What is the ratio of the Imports(as % of merchandise exports) of Seychelles in 1979 to that in 1981?
Give a very brief answer. 0.91. What is the ratio of the Imports(as % of merchandise exports) of Jamaica in 1979 to that in 1982?
Your response must be concise. 0.87. What is the ratio of the Imports(as % of merchandise exports) of Japan in 1979 to that in 1982?
Your response must be concise. 1.19. What is the ratio of the Imports(as % of merchandise exports) in Saudi Arabia in 1979 to that in 1982?
Give a very brief answer. 0.98. What is the ratio of the Imports(as % of merchandise exports) of Seychelles in 1979 to that in 1982?
Give a very brief answer. 0.88. What is the ratio of the Imports(as % of merchandise exports) of Jamaica in 1979 to that in 1983?
Your answer should be compact. 0.98. What is the ratio of the Imports(as % of merchandise exports) of Japan in 1979 to that in 1983?
Provide a short and direct response. 1.1. What is the ratio of the Imports(as % of merchandise exports) of Saudi Arabia in 1979 to that in 1983?
Make the answer very short. 1.04. What is the ratio of the Imports(as % of merchandise exports) of Seychelles in 1979 to that in 1983?
Provide a succinct answer. 0.99. What is the ratio of the Imports(as % of merchandise exports) of Jamaica in 1979 to that in 1984?
Your response must be concise. 0.84. What is the ratio of the Imports(as % of merchandise exports) in Japan in 1979 to that in 1984?
Your response must be concise. 1.09. What is the ratio of the Imports(as % of merchandise exports) of Saudi Arabia in 1979 to that in 1984?
Keep it short and to the point. 0.82. What is the ratio of the Imports(as % of merchandise exports) of Seychelles in 1979 to that in 1984?
Ensure brevity in your answer.  0.9. What is the ratio of the Imports(as % of merchandise exports) of Jamaica in 1980 to that in 1981?
Your response must be concise. 1.09. What is the ratio of the Imports(as % of merchandise exports) in Japan in 1980 to that in 1981?
Your answer should be very brief. 0.93. What is the ratio of the Imports(as % of merchandise exports) of Saudi Arabia in 1980 to that in 1981?
Provide a succinct answer. 0.98. What is the ratio of the Imports(as % of merchandise exports) in Seychelles in 1980 to that in 1981?
Provide a succinct answer. 1.01. What is the ratio of the Imports(as % of merchandise exports) of Jamaica in 1980 to that in 1982?
Offer a terse response. 1.06. What is the ratio of the Imports(as % of merchandise exports) in Japan in 1980 to that in 1982?
Give a very brief answer. 0.95. What is the ratio of the Imports(as % of merchandise exports) of Saudi Arabia in 1980 to that in 1982?
Your response must be concise. 1.09. What is the ratio of the Imports(as % of merchandise exports) in Seychelles in 1980 to that in 1982?
Your answer should be very brief. 0.97. What is the ratio of the Imports(as % of merchandise exports) in Jamaica in 1980 to that in 1983?
Keep it short and to the point. 1.19. What is the ratio of the Imports(as % of merchandise exports) in Japan in 1980 to that in 1983?
Give a very brief answer. 0.88. What is the ratio of the Imports(as % of merchandise exports) in Saudi Arabia in 1980 to that in 1983?
Your answer should be very brief. 1.16. What is the ratio of the Imports(as % of merchandise exports) in Seychelles in 1980 to that in 1983?
Make the answer very short. 1.1. What is the ratio of the Imports(as % of merchandise exports) of Jamaica in 1980 to that in 1984?
Your answer should be very brief. 1.02. What is the ratio of the Imports(as % of merchandise exports) of Japan in 1980 to that in 1984?
Make the answer very short. 0.87. What is the ratio of the Imports(as % of merchandise exports) in Saudi Arabia in 1980 to that in 1984?
Your answer should be compact. 0.91. What is the ratio of the Imports(as % of merchandise exports) in Jamaica in 1981 to that in 1982?
Your response must be concise. 0.97. What is the ratio of the Imports(as % of merchandise exports) of Japan in 1981 to that in 1982?
Keep it short and to the point. 1.02. What is the ratio of the Imports(as % of merchandise exports) in Saudi Arabia in 1981 to that in 1982?
Offer a very short reply. 1.12. What is the ratio of the Imports(as % of merchandise exports) in Seychelles in 1981 to that in 1982?
Provide a succinct answer. 0.97. What is the ratio of the Imports(as % of merchandise exports) in Jamaica in 1981 to that in 1983?
Provide a succinct answer. 1.09. What is the ratio of the Imports(as % of merchandise exports) of Japan in 1981 to that in 1983?
Your response must be concise. 0.95. What is the ratio of the Imports(as % of merchandise exports) of Saudi Arabia in 1981 to that in 1983?
Give a very brief answer. 1.19. What is the ratio of the Imports(as % of merchandise exports) of Seychelles in 1981 to that in 1983?
Ensure brevity in your answer.  1.09. What is the ratio of the Imports(as % of merchandise exports) of Jamaica in 1981 to that in 1984?
Offer a very short reply. 0.93. What is the ratio of the Imports(as % of merchandise exports) of Japan in 1981 to that in 1984?
Provide a succinct answer. 0.93. What is the ratio of the Imports(as % of merchandise exports) of Saudi Arabia in 1981 to that in 1984?
Make the answer very short. 0.93. What is the ratio of the Imports(as % of merchandise exports) in Seychelles in 1981 to that in 1984?
Offer a terse response. 1. What is the ratio of the Imports(as % of merchandise exports) of Jamaica in 1982 to that in 1983?
Ensure brevity in your answer.  1.13. What is the ratio of the Imports(as % of merchandise exports) of Japan in 1982 to that in 1983?
Keep it short and to the point. 0.93. What is the ratio of the Imports(as % of merchandise exports) of Saudi Arabia in 1982 to that in 1983?
Offer a terse response. 1.06. What is the ratio of the Imports(as % of merchandise exports) of Seychelles in 1982 to that in 1983?
Ensure brevity in your answer.  1.12. What is the ratio of the Imports(as % of merchandise exports) in Jamaica in 1982 to that in 1984?
Offer a terse response. 0.96. What is the ratio of the Imports(as % of merchandise exports) in Japan in 1982 to that in 1984?
Give a very brief answer. 0.92. What is the ratio of the Imports(as % of merchandise exports) of Saudi Arabia in 1982 to that in 1984?
Give a very brief answer. 0.83. What is the ratio of the Imports(as % of merchandise exports) of Seychelles in 1982 to that in 1984?
Make the answer very short. 1.03. What is the ratio of the Imports(as % of merchandise exports) of Jamaica in 1983 to that in 1984?
Provide a succinct answer. 0.85. What is the ratio of the Imports(as % of merchandise exports) in Japan in 1983 to that in 1984?
Keep it short and to the point. 0.99. What is the ratio of the Imports(as % of merchandise exports) in Saudi Arabia in 1983 to that in 1984?
Make the answer very short. 0.78. What is the ratio of the Imports(as % of merchandise exports) in Seychelles in 1983 to that in 1984?
Ensure brevity in your answer.  0.92. What is the difference between the highest and the second highest Imports(as % of merchandise exports) of Jamaica?
Give a very brief answer. 2.24. What is the difference between the highest and the second highest Imports(as % of merchandise exports) in Japan?
Give a very brief answer. 1.74. What is the difference between the highest and the second highest Imports(as % of merchandise exports) of Saudi Arabia?
Give a very brief answer. 1.15. What is the difference between the highest and the second highest Imports(as % of merchandise exports) of Seychelles?
Offer a terse response. 2.92. What is the difference between the highest and the lowest Imports(as % of merchandise exports) in Jamaica?
Your response must be concise. 5.77. What is the difference between the highest and the lowest Imports(as % of merchandise exports) in Japan?
Your answer should be very brief. 4.78. What is the difference between the highest and the lowest Imports(as % of merchandise exports) of Saudi Arabia?
Provide a succinct answer. 4.25. What is the difference between the highest and the lowest Imports(as % of merchandise exports) in Seychelles?
Offer a terse response. 5.54. 